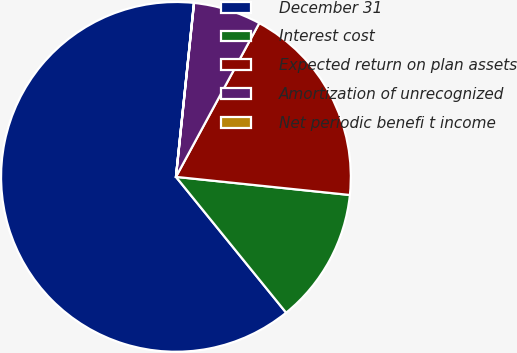Convert chart. <chart><loc_0><loc_0><loc_500><loc_500><pie_chart><fcel>December 31<fcel>Interest cost<fcel>Expected return on plan assets<fcel>Amortization of unrecognized<fcel>Net periodic benefi t income<nl><fcel>62.49%<fcel>12.5%<fcel>18.75%<fcel>6.25%<fcel>0.01%<nl></chart> 